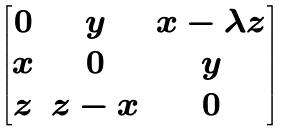Convert formula to latex. <formula><loc_0><loc_0><loc_500><loc_500>\begin{bmatrix} 0 & y & x - \lambda z \\ x & 0 & y \\ z & z - x & 0 \end{bmatrix}</formula> 